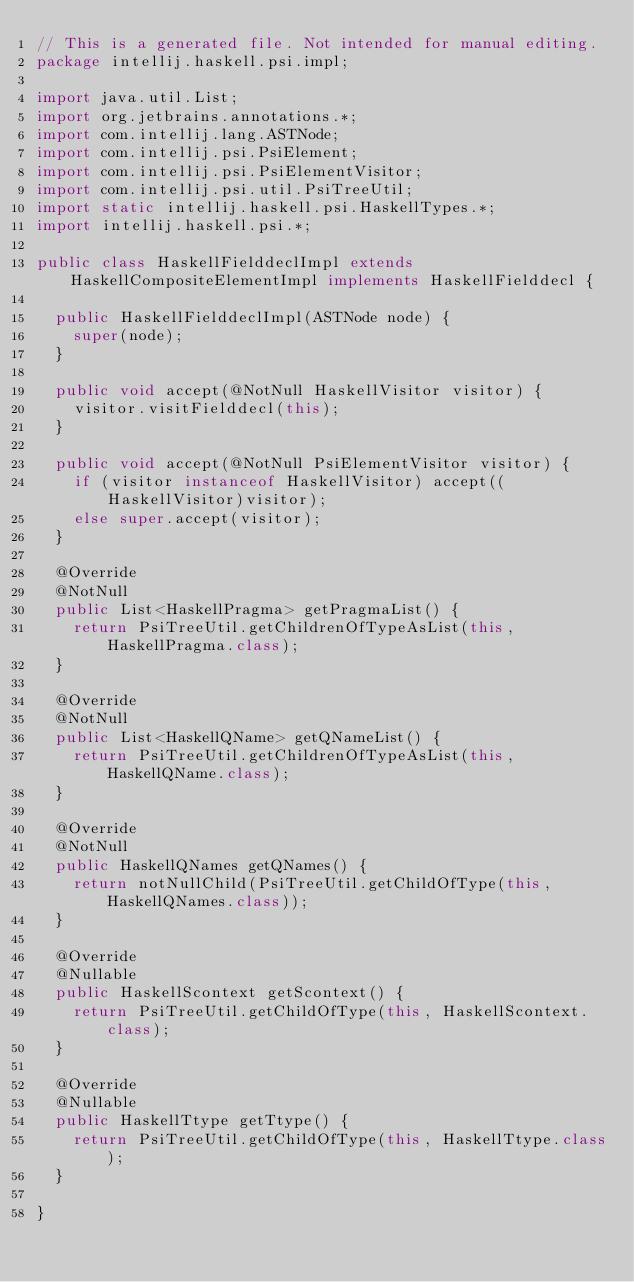<code> <loc_0><loc_0><loc_500><loc_500><_Java_>// This is a generated file. Not intended for manual editing.
package intellij.haskell.psi.impl;

import java.util.List;
import org.jetbrains.annotations.*;
import com.intellij.lang.ASTNode;
import com.intellij.psi.PsiElement;
import com.intellij.psi.PsiElementVisitor;
import com.intellij.psi.util.PsiTreeUtil;
import static intellij.haskell.psi.HaskellTypes.*;
import intellij.haskell.psi.*;

public class HaskellFielddeclImpl extends HaskellCompositeElementImpl implements HaskellFielddecl {

  public HaskellFielddeclImpl(ASTNode node) {
    super(node);
  }

  public void accept(@NotNull HaskellVisitor visitor) {
    visitor.visitFielddecl(this);
  }

  public void accept(@NotNull PsiElementVisitor visitor) {
    if (visitor instanceof HaskellVisitor) accept((HaskellVisitor)visitor);
    else super.accept(visitor);
  }

  @Override
  @NotNull
  public List<HaskellPragma> getPragmaList() {
    return PsiTreeUtil.getChildrenOfTypeAsList(this, HaskellPragma.class);
  }

  @Override
  @NotNull
  public List<HaskellQName> getQNameList() {
    return PsiTreeUtil.getChildrenOfTypeAsList(this, HaskellQName.class);
  }

  @Override
  @NotNull
  public HaskellQNames getQNames() {
    return notNullChild(PsiTreeUtil.getChildOfType(this, HaskellQNames.class));
  }

  @Override
  @Nullable
  public HaskellScontext getScontext() {
    return PsiTreeUtil.getChildOfType(this, HaskellScontext.class);
  }

  @Override
  @Nullable
  public HaskellTtype getTtype() {
    return PsiTreeUtil.getChildOfType(this, HaskellTtype.class);
  }

}
</code> 